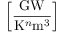Convert formula to latex. <formula><loc_0><loc_0><loc_500><loc_500>\left [ \frac { G W } { K ^ { n } m ^ { 3 } } \right ]</formula> 